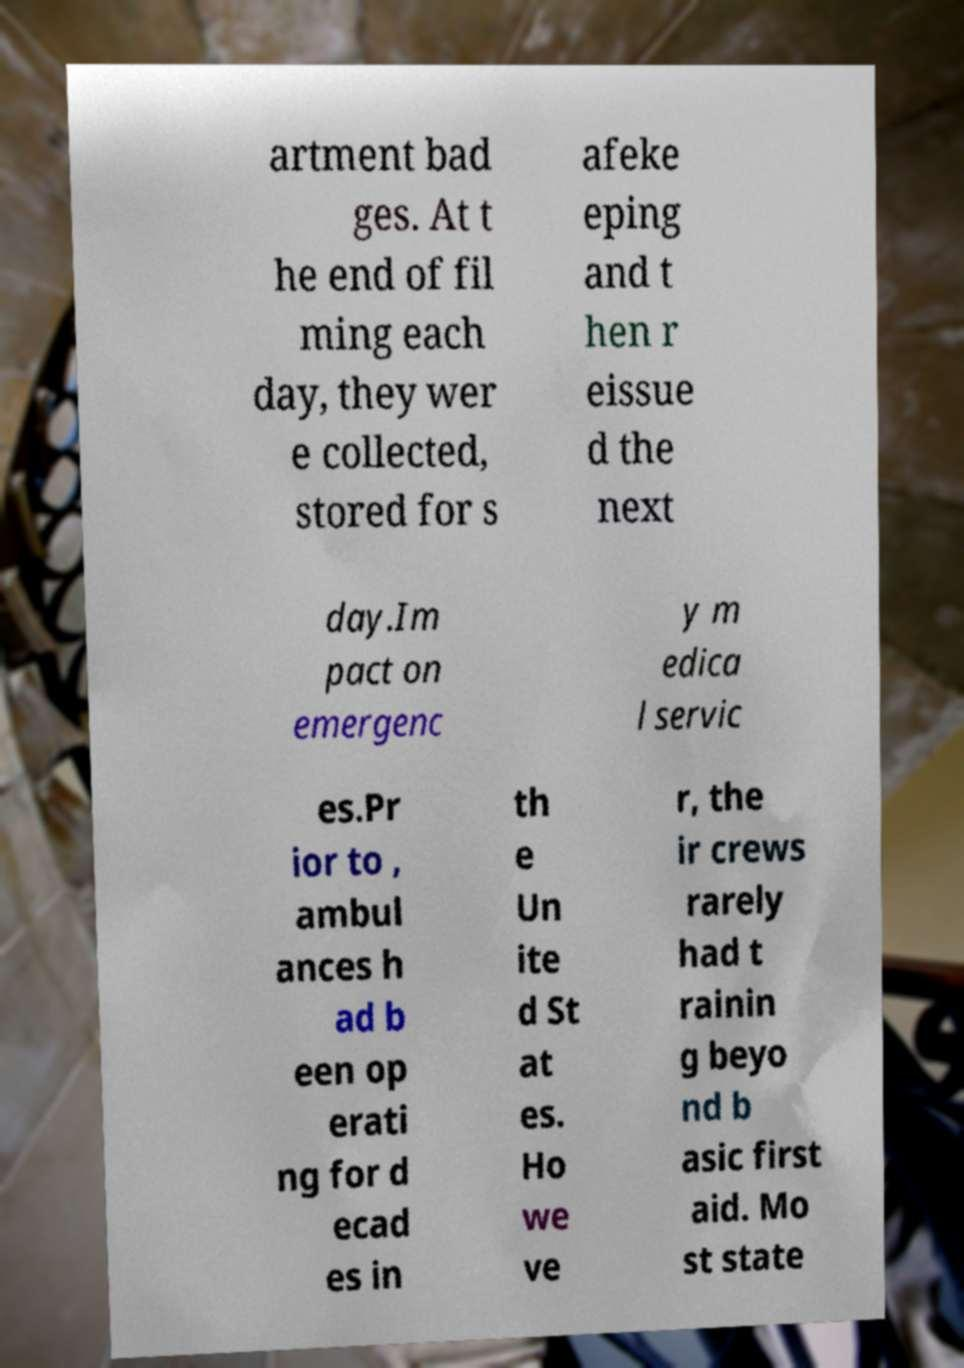What messages or text are displayed in this image? I need them in a readable, typed format. artment bad ges. At t he end of fil ming each day, they wer e collected, stored for s afeke eping and t hen r eissue d the next day.Im pact on emergenc y m edica l servic es.Pr ior to , ambul ances h ad b een op erati ng for d ecad es in th e Un ite d St at es. Ho we ve r, the ir crews rarely had t rainin g beyo nd b asic first aid. Mo st state 